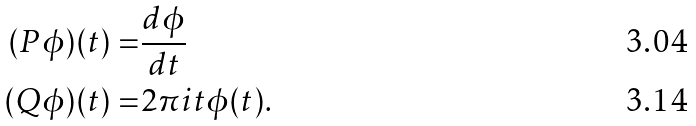Convert formula to latex. <formula><loc_0><loc_0><loc_500><loc_500>( P \phi ) ( t ) = & \frac { d \phi } { d t } \\ ( Q \phi ) ( t ) = & 2 \pi i t \phi ( t ) .</formula> 